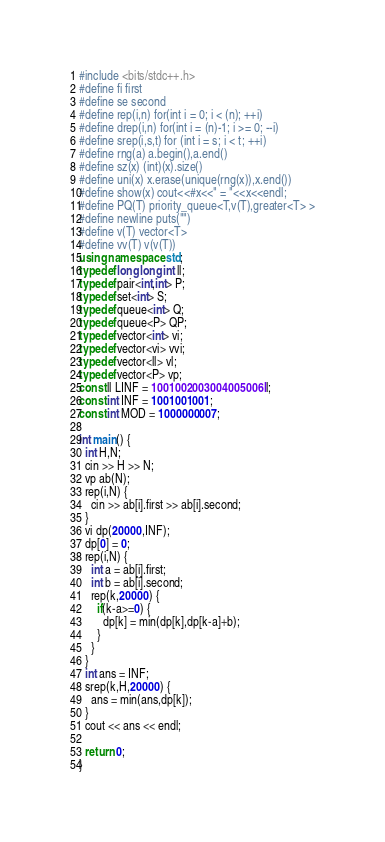Convert code to text. <code><loc_0><loc_0><loc_500><loc_500><_C++_>#include <bits/stdc++.h>
#define fi first
#define se second
#define rep(i,n) for(int i = 0; i < (n); ++i)
#define drep(i,n) for(int i = (n)-1; i >= 0; --i)
#define srep(i,s,t) for (int i = s; i < t; ++i)
#define rng(a) a.begin(),a.end()
#define sz(x) (int)(x).size()
#define uni(x) x.erase(unique(rng(x)),x.end())
#define show(x) cout<<#x<<" = "<<x<<endl;
#define PQ(T) priority_queue<T,v(T),greater<T> >
#define newline puts("")
#define v(T) vector<T>
#define vv(T) v(v(T))
using namespace std;
typedef long long int ll;
typedef pair<int,int> P;
typedef set<int> S;
typedef queue<int> Q;
typedef queue<P> QP;
typedef vector<int> vi;
typedef vector<vi> vvi;
typedef vector<ll> vl;
typedef vector<P> vp;
const ll LINF = 1001002003004005006ll;
const int INF = 1001001001;
const int MOD = 1000000007;
  
int main() {
  int H,N;
  cin >> H >> N;
  vp ab(N);
  rep(i,N) {
    cin >> ab[i].first >> ab[i].second;
  }
  vi dp(20000,INF);
  dp[0] = 0;
  rep(i,N) {
    int a = ab[i].first;
    int b = ab[i].second;
    rep(k,20000) {
      if(k-a>=0) {
        dp[k] = min(dp[k],dp[k-a]+b);
      }
    }
  }
  int ans = INF;
  srep(k,H,20000) {
    ans = min(ans,dp[k]);
  }
  cout << ans << endl;
  
  return 0;
}</code> 